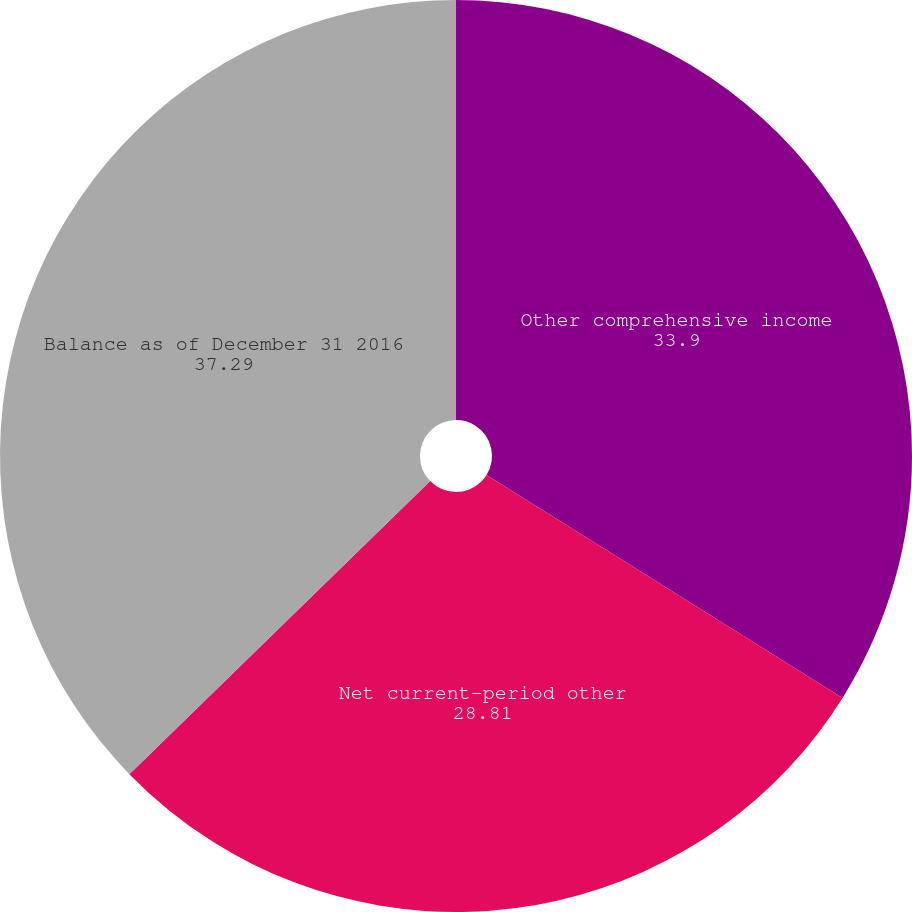Convert chart. <chart><loc_0><loc_0><loc_500><loc_500><pie_chart><fcel>Other comprehensive income<fcel>Net current-period other<fcel>Balance as of December 31 2016<nl><fcel>33.9%<fcel>28.81%<fcel>37.29%<nl></chart> 